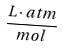Convert formula to latex. <formula><loc_0><loc_0><loc_500><loc_500>\frac { L \cdot a t m } { m o l }</formula> 